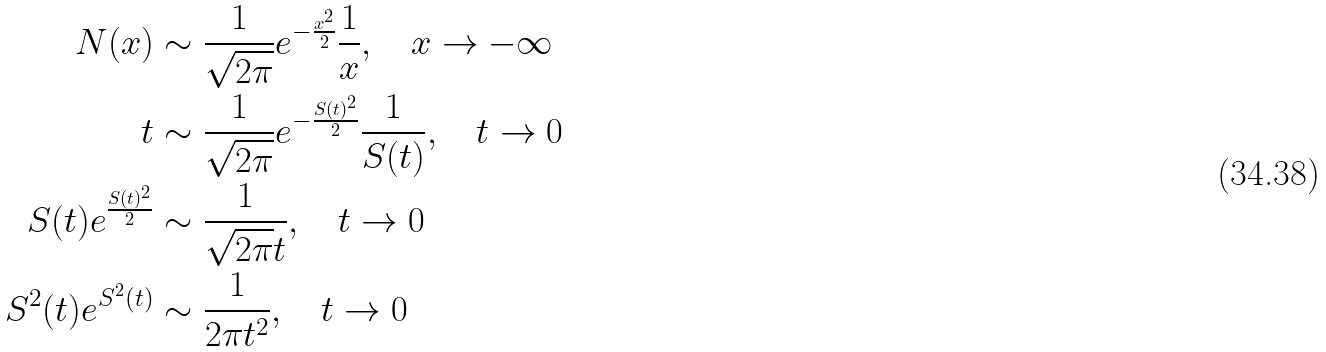<formula> <loc_0><loc_0><loc_500><loc_500>N ( x ) & \sim \frac { 1 } { \sqrt { 2 \pi } } e ^ { - \frac { x ^ { 2 } } { 2 } } \frac { 1 } { x } , \quad x \rightarrow - \infty \\ t & \sim \frac { 1 } { \sqrt { 2 \pi } } e ^ { - \frac { S ( t ) ^ { 2 } } { 2 } } \frac { 1 } { S ( t ) } , \quad t \rightarrow 0 \\ S ( t ) e ^ { \frac { S ( t ) ^ { 2 } } { 2 } } & \sim \frac { 1 } { \sqrt { 2 \pi } t } , \quad t \rightarrow 0 \\ S ^ { 2 } ( t ) e ^ { S ^ { 2 } ( t ) } & \sim \frac { 1 } { 2 \pi t ^ { 2 } } , \quad t \rightarrow 0</formula> 